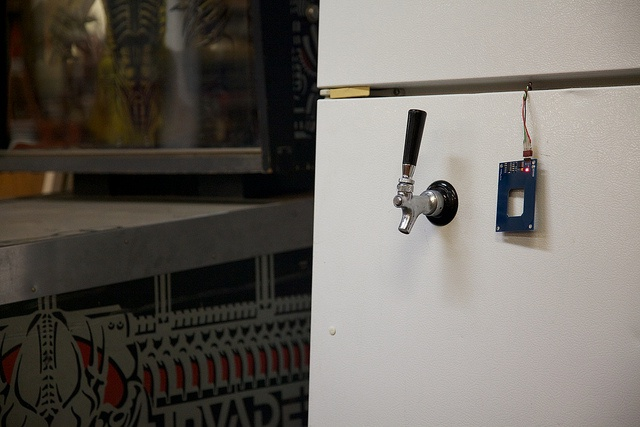Describe the objects in this image and their specific colors. I can see a refrigerator in black, darkgray, and lightgray tones in this image. 